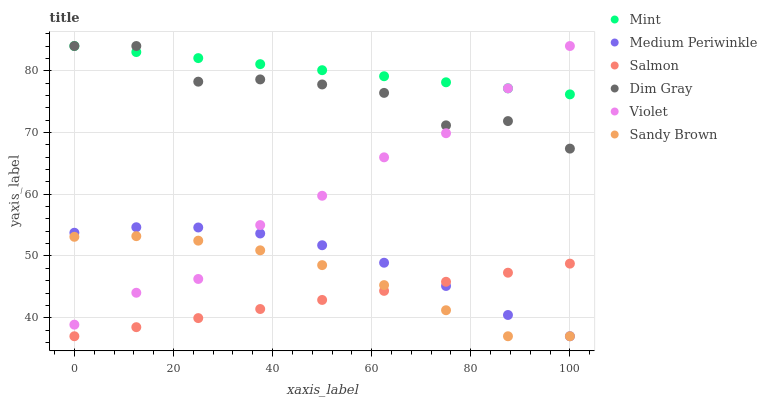Does Salmon have the minimum area under the curve?
Answer yes or no. Yes. Does Mint have the maximum area under the curve?
Answer yes or no. Yes. Does Sandy Brown have the minimum area under the curve?
Answer yes or no. No. Does Sandy Brown have the maximum area under the curve?
Answer yes or no. No. Is Salmon the smoothest?
Answer yes or no. Yes. Is Dim Gray the roughest?
Answer yes or no. Yes. Is Sandy Brown the smoothest?
Answer yes or no. No. Is Sandy Brown the roughest?
Answer yes or no. No. Does Sandy Brown have the lowest value?
Answer yes or no. Yes. Does Violet have the lowest value?
Answer yes or no. No. Does Mint have the highest value?
Answer yes or no. Yes. Does Sandy Brown have the highest value?
Answer yes or no. No. Is Salmon less than Violet?
Answer yes or no. Yes. Is Violet greater than Salmon?
Answer yes or no. Yes. Does Mint intersect Violet?
Answer yes or no. Yes. Is Mint less than Violet?
Answer yes or no. No. Is Mint greater than Violet?
Answer yes or no. No. Does Salmon intersect Violet?
Answer yes or no. No. 